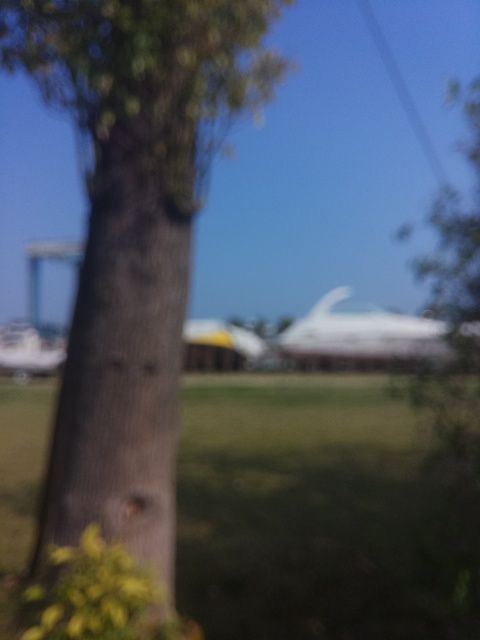How would you describe the lighting in this image? The lighting in this image seems to be natural daylight. It appears soft and diffused, possibly due to a light overcast or the position of the sun. However, it's hard to determine the quality precisely because the image is out of focus. 